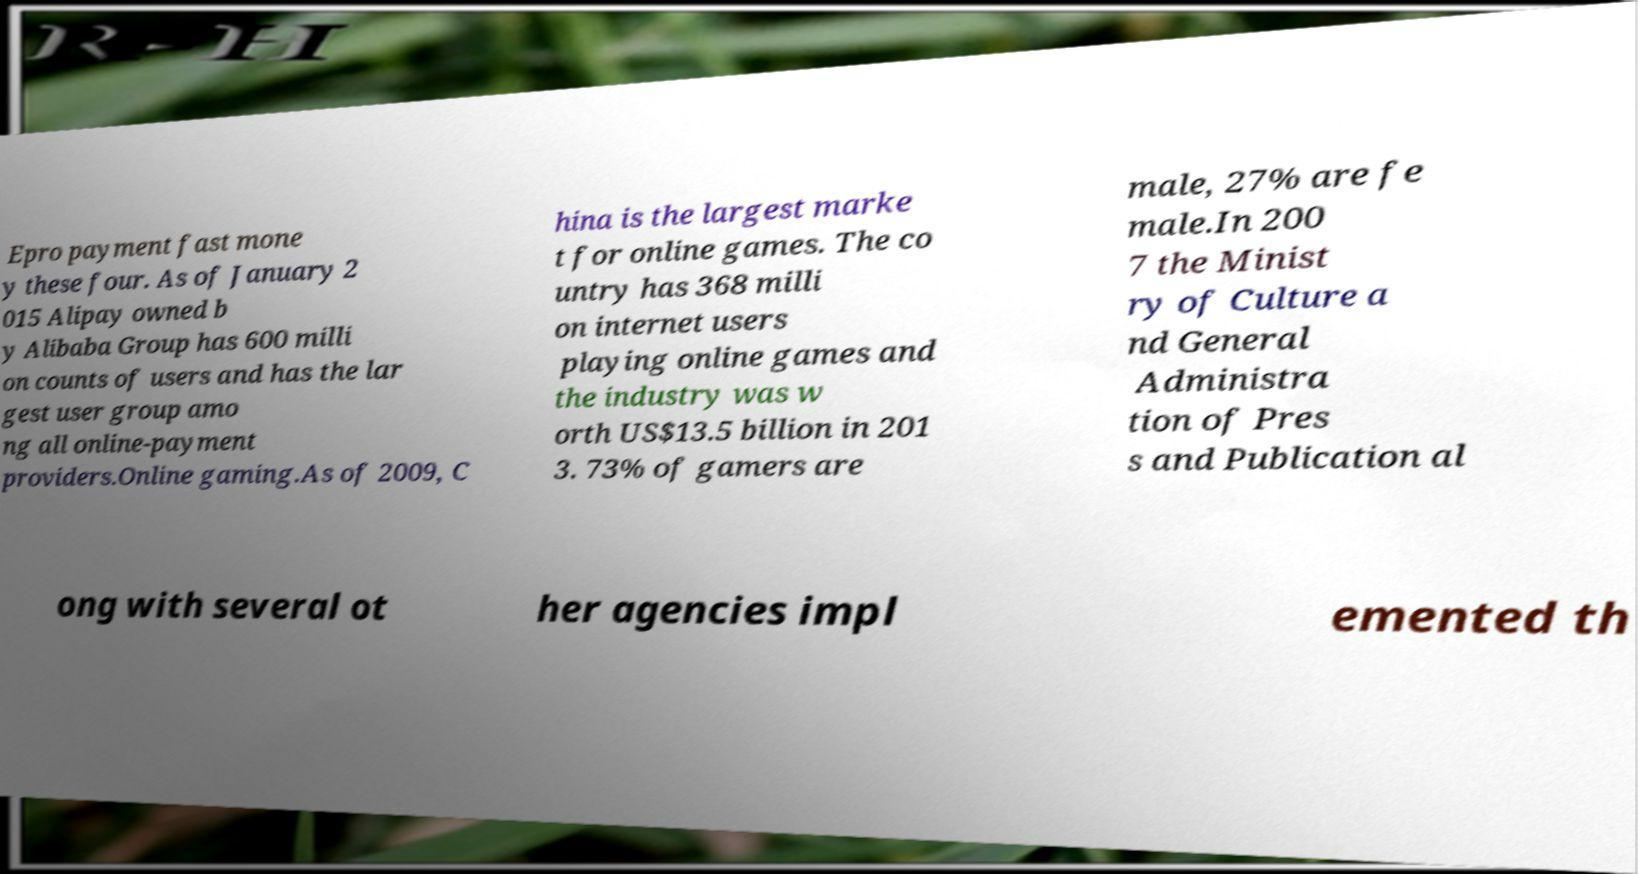I need the written content from this picture converted into text. Can you do that? Epro payment fast mone y these four. As of January 2 015 Alipay owned b y Alibaba Group has 600 milli on counts of users and has the lar gest user group amo ng all online-payment providers.Online gaming.As of 2009, C hina is the largest marke t for online games. The co untry has 368 milli on internet users playing online games and the industry was w orth US$13.5 billion in 201 3. 73% of gamers are male, 27% are fe male.In 200 7 the Minist ry of Culture a nd General Administra tion of Pres s and Publication al ong with several ot her agencies impl emented th 